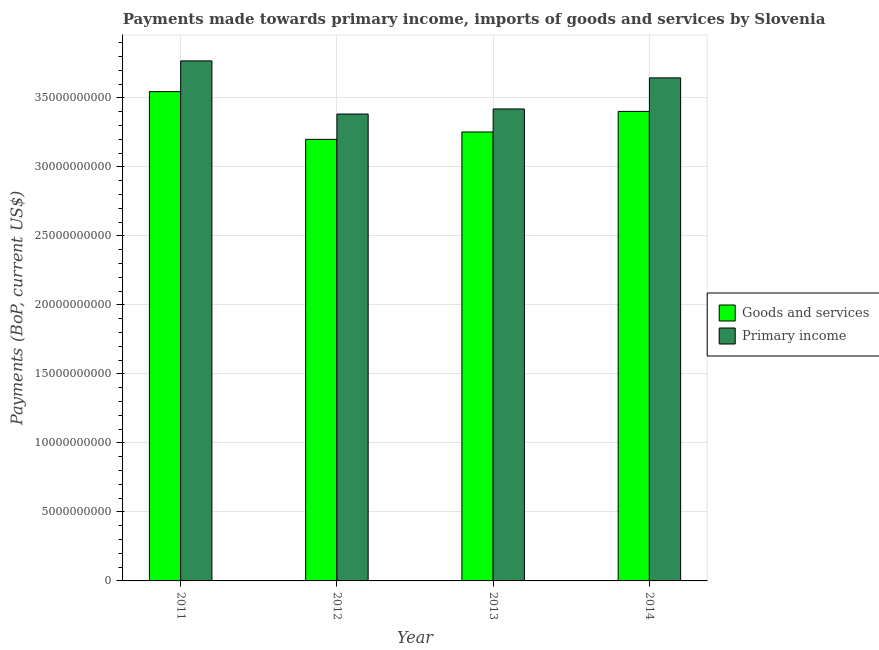How many different coloured bars are there?
Make the answer very short. 2. How many groups of bars are there?
Provide a succinct answer. 4. Are the number of bars per tick equal to the number of legend labels?
Provide a short and direct response. Yes. How many bars are there on the 2nd tick from the right?
Offer a very short reply. 2. In how many cases, is the number of bars for a given year not equal to the number of legend labels?
Your answer should be compact. 0. What is the payments made towards primary income in 2013?
Give a very brief answer. 3.42e+1. Across all years, what is the maximum payments made towards goods and services?
Keep it short and to the point. 3.54e+1. Across all years, what is the minimum payments made towards goods and services?
Provide a short and direct response. 3.20e+1. In which year was the payments made towards goods and services minimum?
Make the answer very short. 2012. What is the total payments made towards goods and services in the graph?
Keep it short and to the point. 1.34e+11. What is the difference between the payments made towards goods and services in 2011 and that in 2012?
Keep it short and to the point. 3.46e+09. What is the difference between the payments made towards primary income in 2012 and the payments made towards goods and services in 2014?
Provide a succinct answer. -2.62e+09. What is the average payments made towards primary income per year?
Provide a succinct answer. 3.55e+1. In the year 2011, what is the difference between the payments made towards goods and services and payments made towards primary income?
Give a very brief answer. 0. What is the ratio of the payments made towards goods and services in 2012 to that in 2013?
Offer a terse response. 0.98. Is the payments made towards goods and services in 2011 less than that in 2012?
Provide a succinct answer. No. What is the difference between the highest and the second highest payments made towards primary income?
Provide a succinct answer. 1.23e+09. What is the difference between the highest and the lowest payments made towards goods and services?
Offer a very short reply. 3.46e+09. In how many years, is the payments made towards primary income greater than the average payments made towards primary income taken over all years?
Provide a short and direct response. 2. Is the sum of the payments made towards primary income in 2011 and 2014 greater than the maximum payments made towards goods and services across all years?
Offer a very short reply. Yes. What does the 1st bar from the left in 2011 represents?
Provide a succinct answer. Goods and services. What does the 2nd bar from the right in 2011 represents?
Your answer should be very brief. Goods and services. How many years are there in the graph?
Your answer should be compact. 4. What is the difference between two consecutive major ticks on the Y-axis?
Offer a very short reply. 5.00e+09. Are the values on the major ticks of Y-axis written in scientific E-notation?
Make the answer very short. No. Does the graph contain any zero values?
Offer a very short reply. No. Does the graph contain grids?
Make the answer very short. Yes. How are the legend labels stacked?
Ensure brevity in your answer.  Vertical. What is the title of the graph?
Your response must be concise. Payments made towards primary income, imports of goods and services by Slovenia. What is the label or title of the Y-axis?
Offer a very short reply. Payments (BoP, current US$). What is the Payments (BoP, current US$) in Goods and services in 2011?
Your answer should be very brief. 3.54e+1. What is the Payments (BoP, current US$) of Primary income in 2011?
Make the answer very short. 3.77e+1. What is the Payments (BoP, current US$) in Goods and services in 2012?
Provide a succinct answer. 3.20e+1. What is the Payments (BoP, current US$) of Primary income in 2012?
Offer a very short reply. 3.38e+1. What is the Payments (BoP, current US$) in Goods and services in 2013?
Give a very brief answer. 3.25e+1. What is the Payments (BoP, current US$) of Primary income in 2013?
Provide a succinct answer. 3.42e+1. What is the Payments (BoP, current US$) of Goods and services in 2014?
Give a very brief answer. 3.40e+1. What is the Payments (BoP, current US$) of Primary income in 2014?
Keep it short and to the point. 3.64e+1. Across all years, what is the maximum Payments (BoP, current US$) in Goods and services?
Offer a very short reply. 3.54e+1. Across all years, what is the maximum Payments (BoP, current US$) in Primary income?
Your response must be concise. 3.77e+1. Across all years, what is the minimum Payments (BoP, current US$) in Goods and services?
Offer a very short reply. 3.20e+1. Across all years, what is the minimum Payments (BoP, current US$) in Primary income?
Make the answer very short. 3.38e+1. What is the total Payments (BoP, current US$) in Goods and services in the graph?
Give a very brief answer. 1.34e+11. What is the total Payments (BoP, current US$) of Primary income in the graph?
Your response must be concise. 1.42e+11. What is the difference between the Payments (BoP, current US$) of Goods and services in 2011 and that in 2012?
Make the answer very short. 3.46e+09. What is the difference between the Payments (BoP, current US$) of Primary income in 2011 and that in 2012?
Your answer should be compact. 3.85e+09. What is the difference between the Payments (BoP, current US$) of Goods and services in 2011 and that in 2013?
Your answer should be compact. 2.92e+09. What is the difference between the Payments (BoP, current US$) of Primary income in 2011 and that in 2013?
Give a very brief answer. 3.48e+09. What is the difference between the Payments (BoP, current US$) of Goods and services in 2011 and that in 2014?
Your answer should be compact. 1.43e+09. What is the difference between the Payments (BoP, current US$) of Primary income in 2011 and that in 2014?
Offer a very short reply. 1.23e+09. What is the difference between the Payments (BoP, current US$) of Goods and services in 2012 and that in 2013?
Ensure brevity in your answer.  -5.35e+08. What is the difference between the Payments (BoP, current US$) in Primary income in 2012 and that in 2013?
Ensure brevity in your answer.  -3.69e+08. What is the difference between the Payments (BoP, current US$) in Goods and services in 2012 and that in 2014?
Offer a terse response. -2.03e+09. What is the difference between the Payments (BoP, current US$) of Primary income in 2012 and that in 2014?
Make the answer very short. -2.62e+09. What is the difference between the Payments (BoP, current US$) of Goods and services in 2013 and that in 2014?
Make the answer very short. -1.49e+09. What is the difference between the Payments (BoP, current US$) in Primary income in 2013 and that in 2014?
Ensure brevity in your answer.  -2.25e+09. What is the difference between the Payments (BoP, current US$) in Goods and services in 2011 and the Payments (BoP, current US$) in Primary income in 2012?
Keep it short and to the point. 1.62e+09. What is the difference between the Payments (BoP, current US$) of Goods and services in 2011 and the Payments (BoP, current US$) of Primary income in 2013?
Your answer should be very brief. 1.26e+09. What is the difference between the Payments (BoP, current US$) of Goods and services in 2011 and the Payments (BoP, current US$) of Primary income in 2014?
Your response must be concise. -9.98e+08. What is the difference between the Payments (BoP, current US$) of Goods and services in 2012 and the Payments (BoP, current US$) of Primary income in 2013?
Provide a short and direct response. -2.20e+09. What is the difference between the Payments (BoP, current US$) in Goods and services in 2012 and the Payments (BoP, current US$) in Primary income in 2014?
Make the answer very short. -4.46e+09. What is the difference between the Payments (BoP, current US$) in Goods and services in 2013 and the Payments (BoP, current US$) in Primary income in 2014?
Ensure brevity in your answer.  -3.92e+09. What is the average Payments (BoP, current US$) of Goods and services per year?
Ensure brevity in your answer.  3.35e+1. What is the average Payments (BoP, current US$) in Primary income per year?
Ensure brevity in your answer.  3.55e+1. In the year 2011, what is the difference between the Payments (BoP, current US$) of Goods and services and Payments (BoP, current US$) of Primary income?
Make the answer very short. -2.23e+09. In the year 2012, what is the difference between the Payments (BoP, current US$) of Goods and services and Payments (BoP, current US$) of Primary income?
Provide a succinct answer. -1.83e+09. In the year 2013, what is the difference between the Payments (BoP, current US$) in Goods and services and Payments (BoP, current US$) in Primary income?
Ensure brevity in your answer.  -1.67e+09. In the year 2014, what is the difference between the Payments (BoP, current US$) in Goods and services and Payments (BoP, current US$) in Primary income?
Give a very brief answer. -2.43e+09. What is the ratio of the Payments (BoP, current US$) of Goods and services in 2011 to that in 2012?
Make the answer very short. 1.11. What is the ratio of the Payments (BoP, current US$) of Primary income in 2011 to that in 2012?
Make the answer very short. 1.11. What is the ratio of the Payments (BoP, current US$) of Goods and services in 2011 to that in 2013?
Provide a short and direct response. 1.09. What is the ratio of the Payments (BoP, current US$) in Primary income in 2011 to that in 2013?
Provide a succinct answer. 1.1. What is the ratio of the Payments (BoP, current US$) in Goods and services in 2011 to that in 2014?
Keep it short and to the point. 1.04. What is the ratio of the Payments (BoP, current US$) in Primary income in 2011 to that in 2014?
Ensure brevity in your answer.  1.03. What is the ratio of the Payments (BoP, current US$) in Goods and services in 2012 to that in 2013?
Offer a terse response. 0.98. What is the ratio of the Payments (BoP, current US$) of Goods and services in 2012 to that in 2014?
Offer a very short reply. 0.94. What is the ratio of the Payments (BoP, current US$) of Primary income in 2012 to that in 2014?
Offer a very short reply. 0.93. What is the ratio of the Payments (BoP, current US$) in Goods and services in 2013 to that in 2014?
Your answer should be compact. 0.96. What is the ratio of the Payments (BoP, current US$) in Primary income in 2013 to that in 2014?
Keep it short and to the point. 0.94. What is the difference between the highest and the second highest Payments (BoP, current US$) in Goods and services?
Provide a succinct answer. 1.43e+09. What is the difference between the highest and the second highest Payments (BoP, current US$) of Primary income?
Make the answer very short. 1.23e+09. What is the difference between the highest and the lowest Payments (BoP, current US$) of Goods and services?
Provide a short and direct response. 3.46e+09. What is the difference between the highest and the lowest Payments (BoP, current US$) in Primary income?
Ensure brevity in your answer.  3.85e+09. 